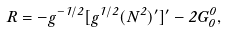<formula> <loc_0><loc_0><loc_500><loc_500>R = - g ^ { - 1 / 2 } [ g ^ { 1 / 2 } ( N ^ { 2 } ) ^ { \prime } ] ^ { \prime } - 2 G _ { 0 } ^ { 0 } ,</formula> 